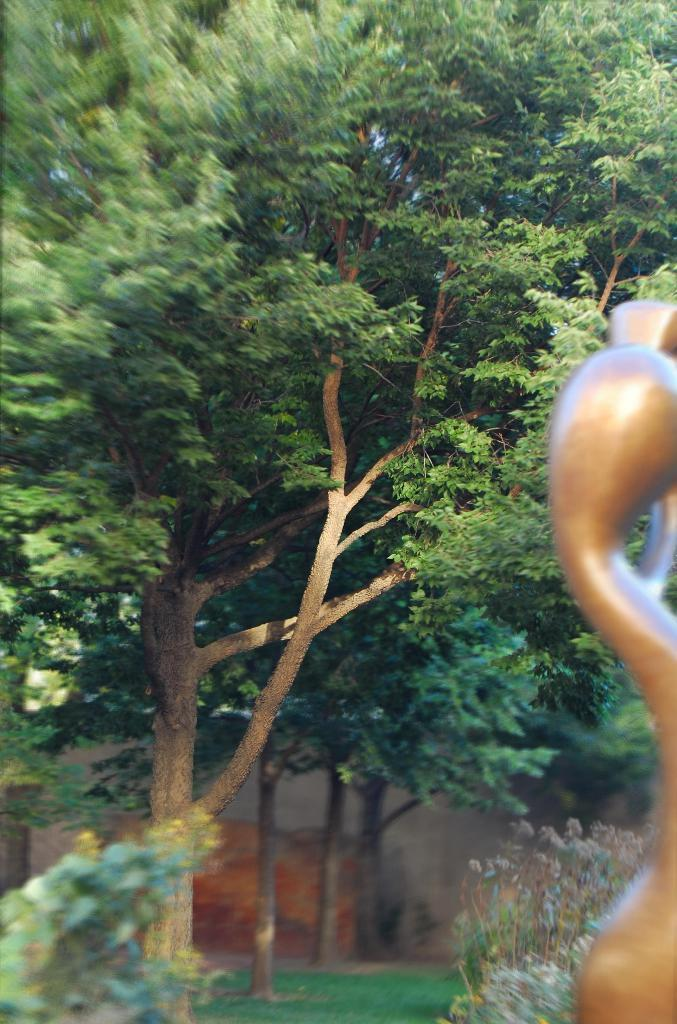What type of vegetation is present in the image? There is a group of trees and plants in the image. What can be seen on the right side of the image? There is an object on the right side of the image. What type of ground cover is visible at the bottom of the image? There is grass visible at the bottom of the image. What is visible in the background of the image? There is a wall in the background of the image. What type of mint is growing on the stage in the image? There is no mint or stage present in the image; it features a group of trees and plants, an object on the right side, grass at the bottom, and a wall in the background. 